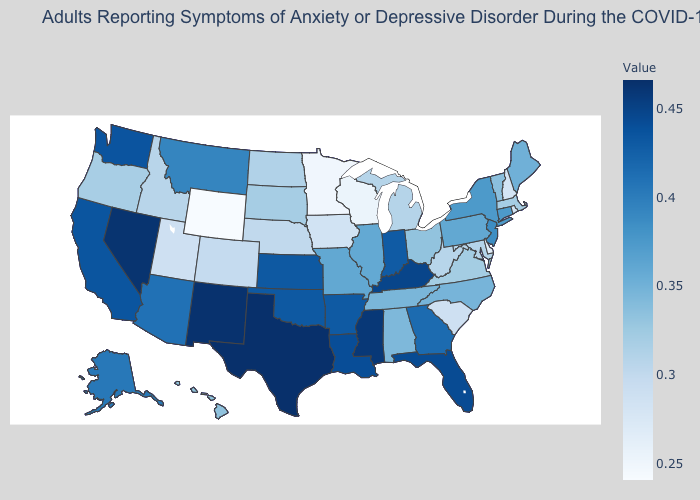Is the legend a continuous bar?
Write a very short answer. Yes. Does New Hampshire have the lowest value in the Northeast?
Give a very brief answer. Yes. Does Minnesota have the lowest value in the MidWest?
Write a very short answer. Yes. Does Wyoming have the lowest value in the USA?
Be succinct. Yes. Among the states that border Virginia , which have the lowest value?
Keep it brief. West Virginia. 